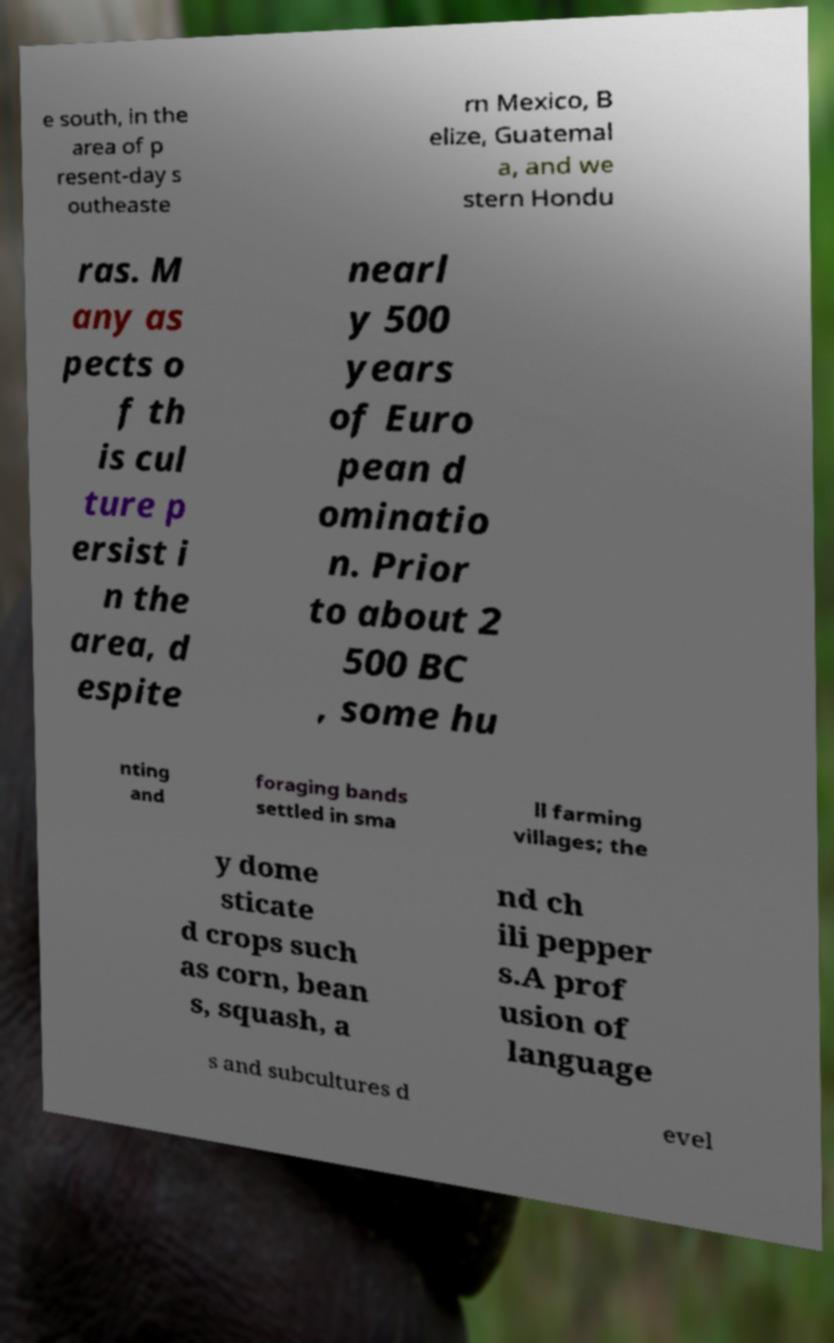Could you extract and type out the text from this image? e south, in the area of p resent-day s outheaste rn Mexico, B elize, Guatemal a, and we stern Hondu ras. M any as pects o f th is cul ture p ersist i n the area, d espite nearl y 500 years of Euro pean d ominatio n. Prior to about 2 500 BC , some hu nting and foraging bands settled in sma ll farming villages; the y dome sticate d crops such as corn, bean s, squash, a nd ch ili pepper s.A prof usion of language s and subcultures d evel 